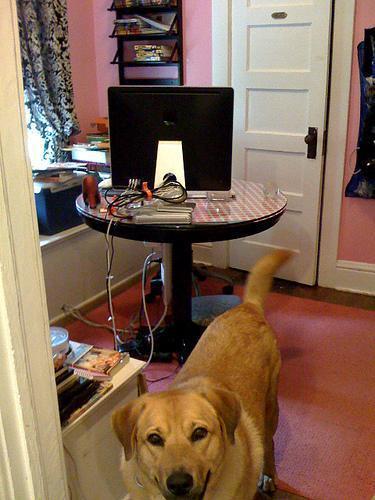How many people are wearing orange jackets?
Give a very brief answer. 0. 